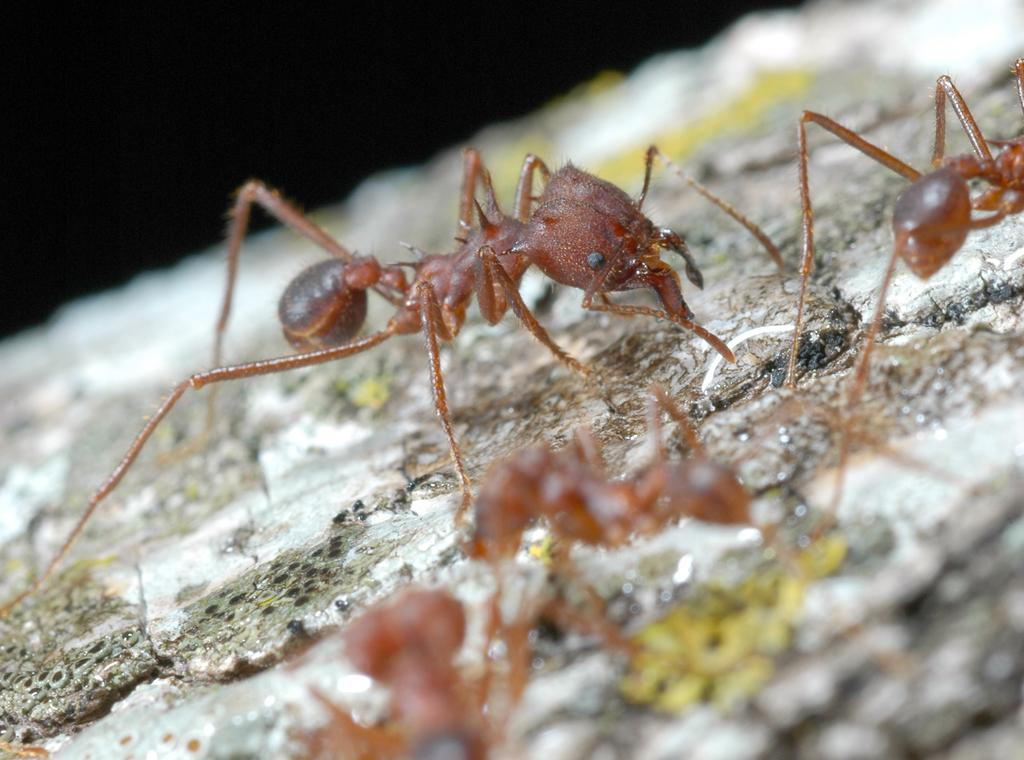What type of creatures can be seen in the image? There are ants in the image. What size of alarm is present in the image? There is no alarm present in the image; it only features ants. What type of division can be seen among the ants in the image? There is no division among the ants visible in the image. 